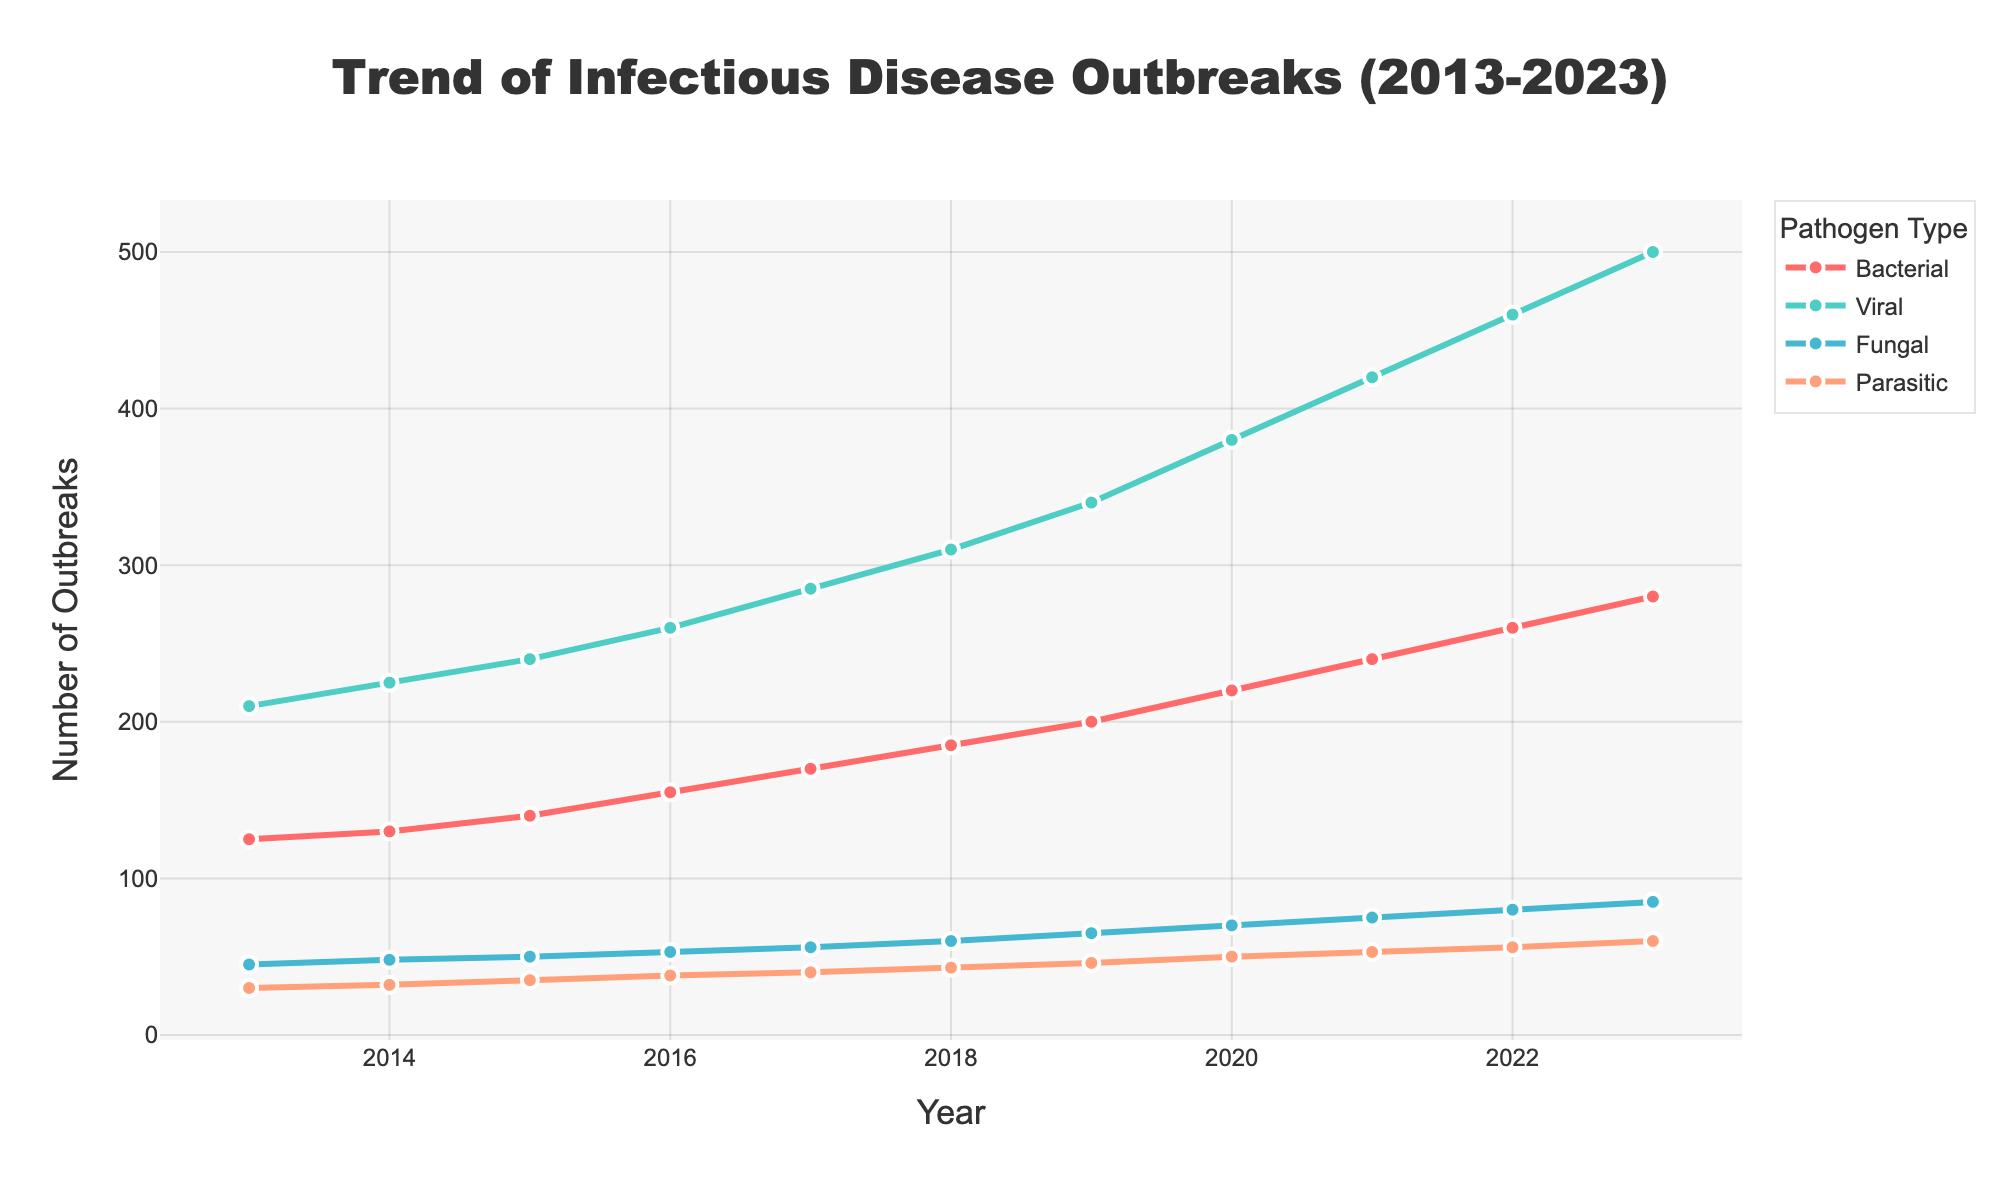What's the total number of viral outbreaks in 2020 and 2021? The number of viral outbreaks in 2020 is 380 and in 2021 is 420. Adding these two numbers together: 380 + 420 = 800
Answer: 800 Which pathogen type had the highest number of outbreaks consistently over the years 2013-2023? By analyzing the trends in the figure, the viral category has the highest number of outbreaks each year from 2013 to 2023 consistently.
Answer: Viral How did the number of bacterial outbreaks change from 2015 to 2020? In 2015, there were 140 bacterial outbreaks, and in 2020, there were 220. The change is calculated as 220 - 140 = 80. Therefore, there was an increase of 80 bacterial outbreaks.
Answer: Increase of 80 What is the difference in the number of fungal outbreaks between 2022 and 2023? The number of fungal outbreaks in 2022 is 80, and in 2023 is 85. The difference is calculated as 85 - 80 = 5. So, the difference is 5.
Answer: 5 Which pathogen had the least number of outbreaks in 2017? According to the figure, in 2017, parasitic outbreaks were the least, with only 40 cases.
Answer: Parasitic What is the average number of parasitic outbreaks from 2013 to 2023? Summing up the numbers for parasitic outbreaks from 2013 to 2023 gives: 30 + 32 + 35 + 38 + 40 + 43 + 46 + 50 + 53 + 56 + 60 = 483. The average is 483 divided by 11 years, which is approximately 43.91
Answer: 43.91 Which year showed the highest increase in viral outbreaks compared to the previous year? By examining the yearly increments: 
2014-2013 = 225-210 = 15
2015-2014 = 240-225 = 15
2016-2015 = 260-240 = 20
2017-2016 = 285-260 = 25
2018-2017 = 310-285 = 25
2019-2018 = 340-310 = 30
2020-2019 = 380-340 = 40
2021-2020 = 420-380 = 40
2022-2021 = 460-420 = 40
2023-2022 = 500-460 = 40
The highest increase of 40 occurred in the years 2020-2021 and 2021-2022 and 2022-2023.
Answer: 2020-2021 and 2021-2022 and 2022-2023 From 2013 to 2023, which pathogen type showed the most consistent linear increase in outbreaks? The bacterial category, when observing the figure, shows a fairly consistent linear increase in its trendline from 2013 to 2023, indicated by equally spaced increments over time.
Answer: Bacterial What is the combined total number of outbreaks for all pathogen types in 2023? Summing the numbers for 2023 for each pathogen type gives: 280 (Bacterial) + 500 (Viral) + 85 (Fungal) + 60 (Parasitic) = 925.
Answer: 925 